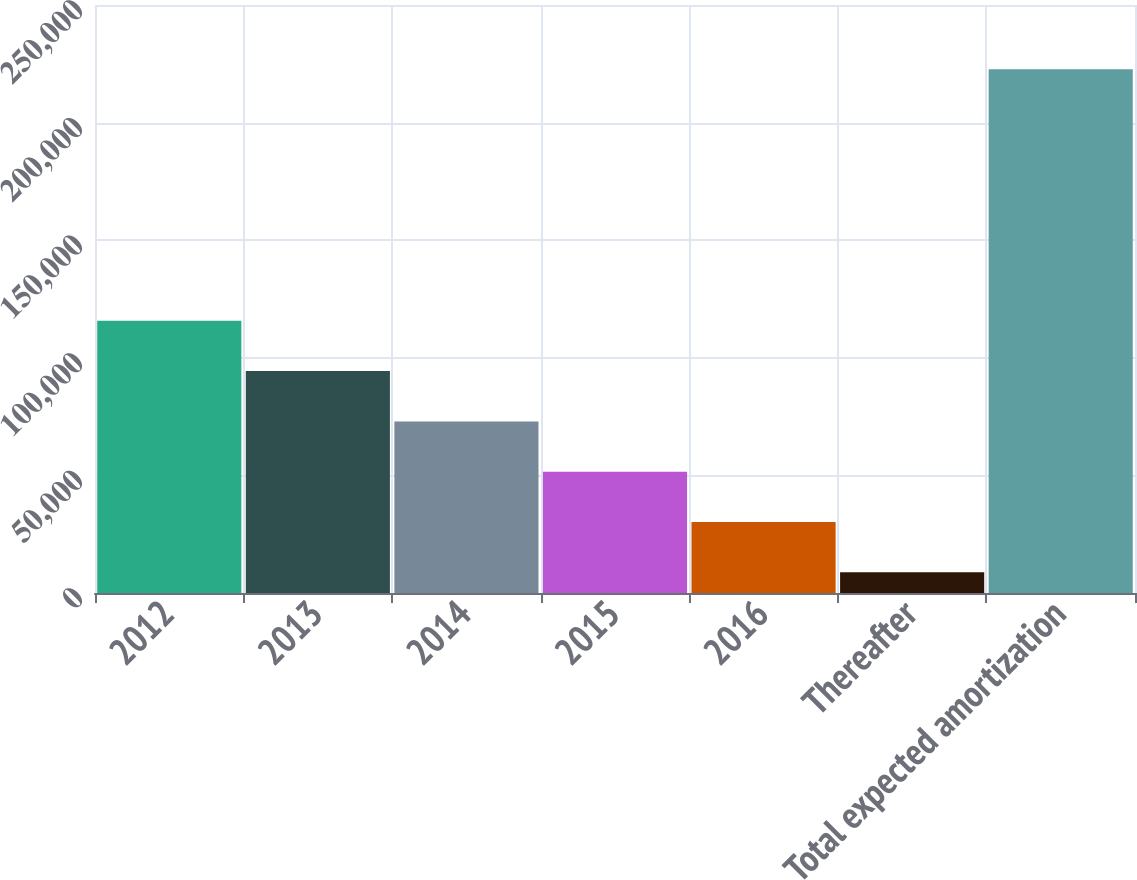Convert chart to OTSL. <chart><loc_0><loc_0><loc_500><loc_500><bar_chart><fcel>2012<fcel>2013<fcel>2014<fcel>2015<fcel>2016<fcel>Thereafter<fcel>Total expected amortization<nl><fcel>115735<fcel>94343.2<fcel>72951.4<fcel>51559.6<fcel>30167.8<fcel>8776<fcel>222694<nl></chart> 